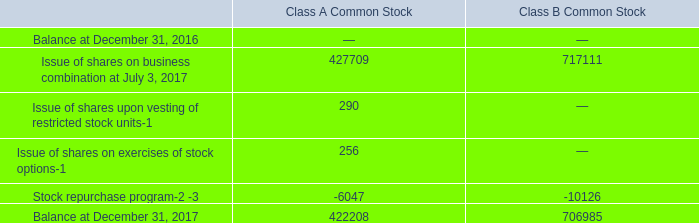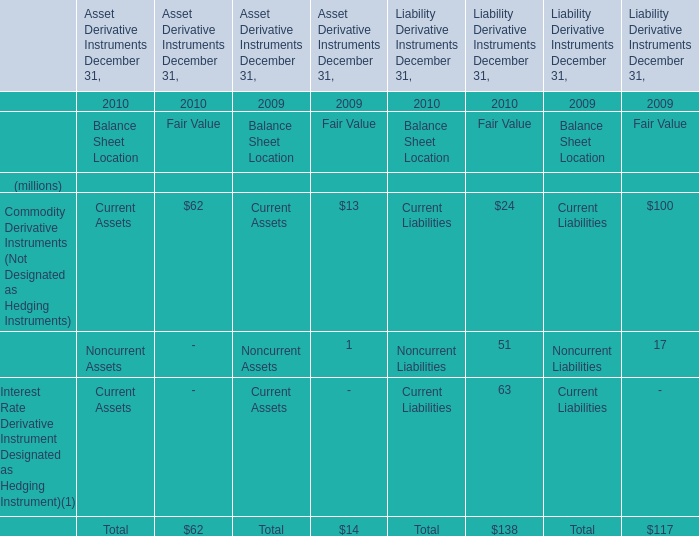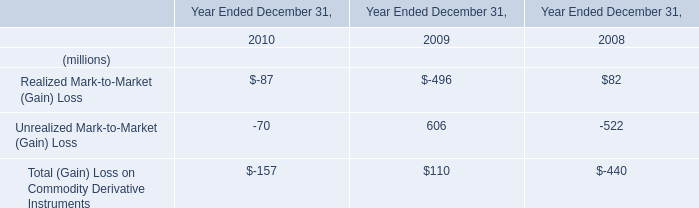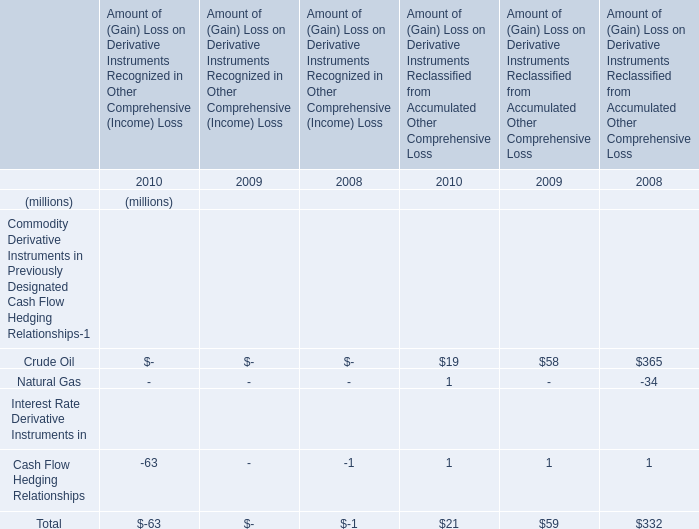How much is 2008's Realized Mark-to-Market (Gain) Loss less than 2009's Unrealized Mark-to-Market (Gain) Loss? (in million) 
Computations: (606 - 82)
Answer: 524.0. 